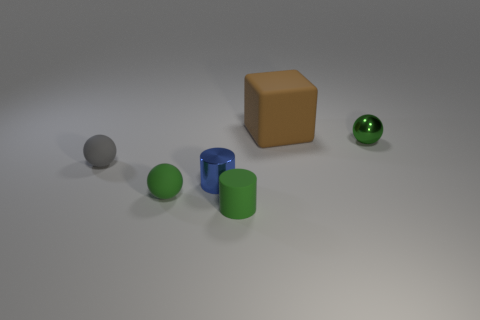Add 3 tiny blue shiny objects. How many objects exist? 9 Subtract all green metal spheres. How many spheres are left? 2 Subtract all green cylinders. How many cylinders are left? 1 Subtract all cylinders. How many objects are left? 4 Subtract all yellow spheres. Subtract all blue blocks. How many spheres are left? 3 Subtract all purple spheres. How many green cylinders are left? 1 Subtract all big yellow shiny objects. Subtract all large brown rubber objects. How many objects are left? 5 Add 1 blue cylinders. How many blue cylinders are left? 2 Add 4 blue cylinders. How many blue cylinders exist? 5 Subtract 0 red cylinders. How many objects are left? 6 